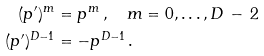<formula> <loc_0><loc_0><loc_500><loc_500>( p ^ { \prime } ) ^ { m } & = p ^ { m } \, , \quad m = 0 , \dots , D \, - \, 2 \\ ( p ^ { \prime } ) ^ { D - 1 } & = - p ^ { D - 1 } \, .</formula> 